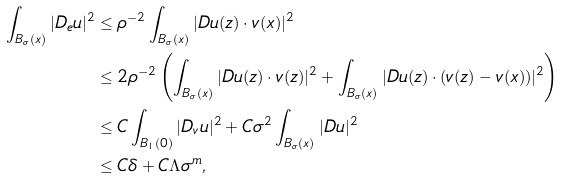Convert formula to latex. <formula><loc_0><loc_0><loc_500><loc_500>\int _ { B _ { \sigma } ( x ) } | D _ { e } u | ^ { 2 } & \leq \rho ^ { - 2 } \int _ { B _ { \sigma } ( x ) } | D u ( z ) \cdot v ( x ) | ^ { 2 } \\ & \leq 2 \rho ^ { - 2 } \left ( \int _ { B _ { \sigma } ( x ) } | D u ( z ) \cdot v ( z ) | ^ { 2 } + \int _ { B _ { \sigma } ( x ) } | D u ( z ) \cdot ( v ( z ) - v ( x ) ) | ^ { 2 } \right ) \\ & \leq C \int _ { B _ { 1 } ( 0 ) } | D _ { v } u | ^ { 2 } + C \sigma ^ { 2 } \int _ { B _ { \sigma } ( x ) } | D u | ^ { 2 } \\ & \leq C \delta + C \Lambda \sigma ^ { m } ,</formula> 